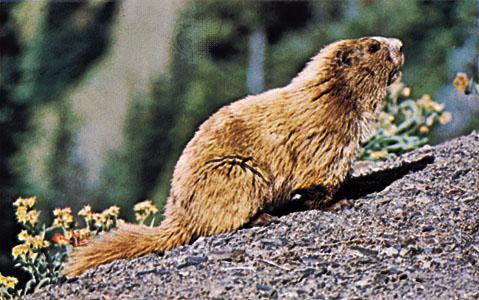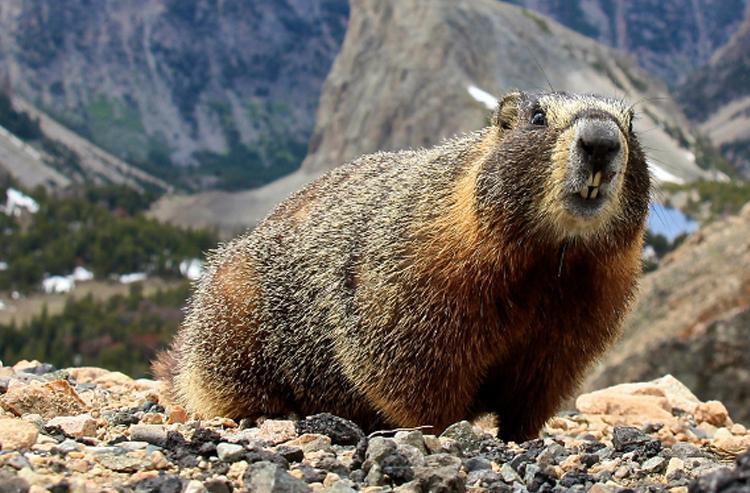The first image is the image on the left, the second image is the image on the right. Analyze the images presented: Is the assertion "The animal in one of the images is lying down." valid? Answer yes or no. No. 